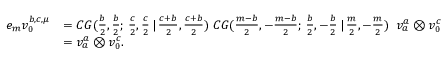<formula> <loc_0><loc_0><loc_500><loc_500>\begin{array} { r l } { e _ { m } v _ { 0 } ^ { b , c , \mu } } & { = C G ( \frac { b } { 2 } , \frac { b } { 2 } ; \, \frac { c } { 2 } , \frac { c } { 2 } \, | \, \frac { c + b } { 2 } , \frac { c + b } { 2 } ) \, C G ( \frac { m - b } { 2 } , - \frac { m - b } { 2 } ; \, \frac { b } { 2 } , - \frac { b } { 2 } \, | \, \frac { m } { 2 } , - \frac { m } { 2 } ) \, v _ { a } ^ { a } \otimes v _ { 0 } ^ { c } } \\ & { = v _ { a } ^ { a } \otimes v _ { 0 } ^ { c } . } \end{array}</formula> 